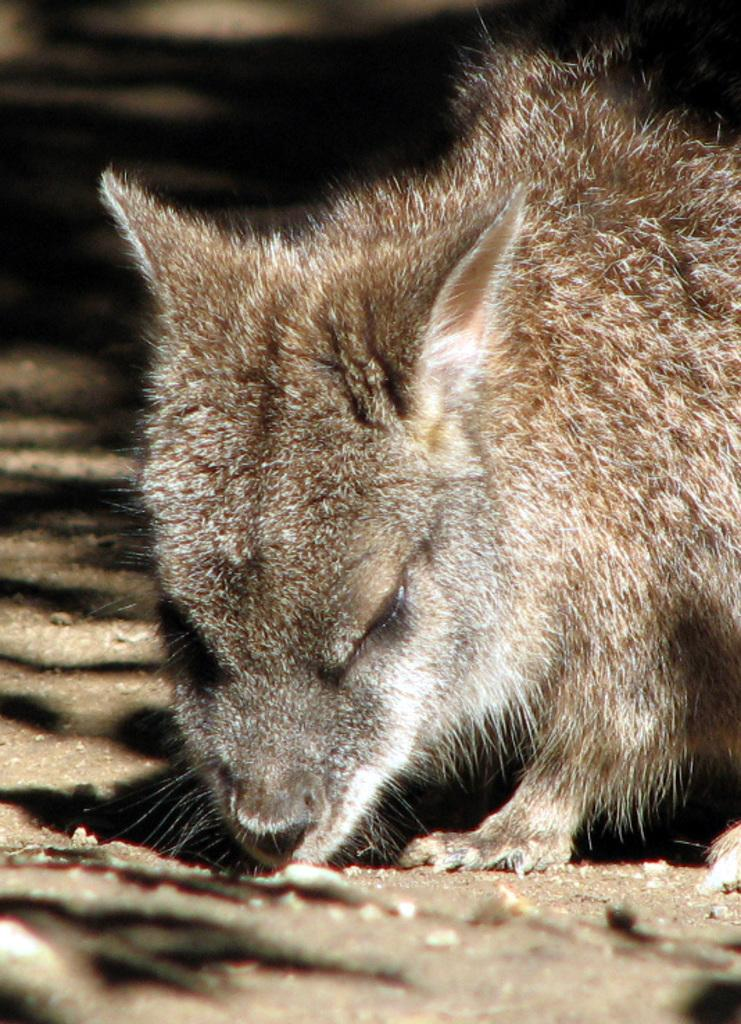What type of creature is present in the image? There is an animal in the image. Can you describe the position of the animal in the image? The animal is standing on the ground. What color is the tent in the image? There is no tent present in the image. How does the crack in the image affect the animal's behavior? There is no crack present in the image, so it does not affect the animal's behavior. 